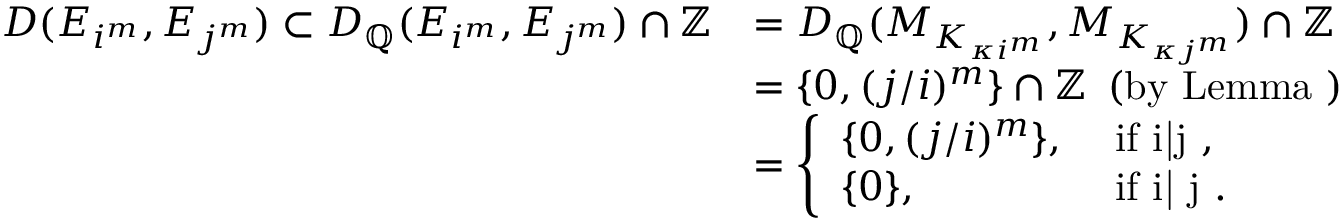Convert formula to latex. <formula><loc_0><loc_0><loc_500><loc_500>\begin{array} { r l } { D ( E _ { i ^ { m } } , E _ { j ^ { m } } ) \subset D _ { \mathbb { Q } } ( E _ { i ^ { m } } , E _ { j ^ { m } } ) \cap \mathbb { Z } } & { = D _ { \mathbb { Q } } ( M _ { K _ { \kappa i ^ { m } } } , M _ { K _ { \kappa j ^ { m } } } ) \cap \mathbb { Z } } \\ & { = \{ 0 , ( j / i ) ^ { m } \} \cap \mathbb { Z } \, ( b y L e m m a ) } \\ & { = \left \{ \begin{array} { l l } { \{ 0 , ( j / i ) ^ { m } \} , } & { i f i | j , } \\ { \{ 0 \} , } & { i f i { \not | } j . } \end{array} } \end{array}</formula> 